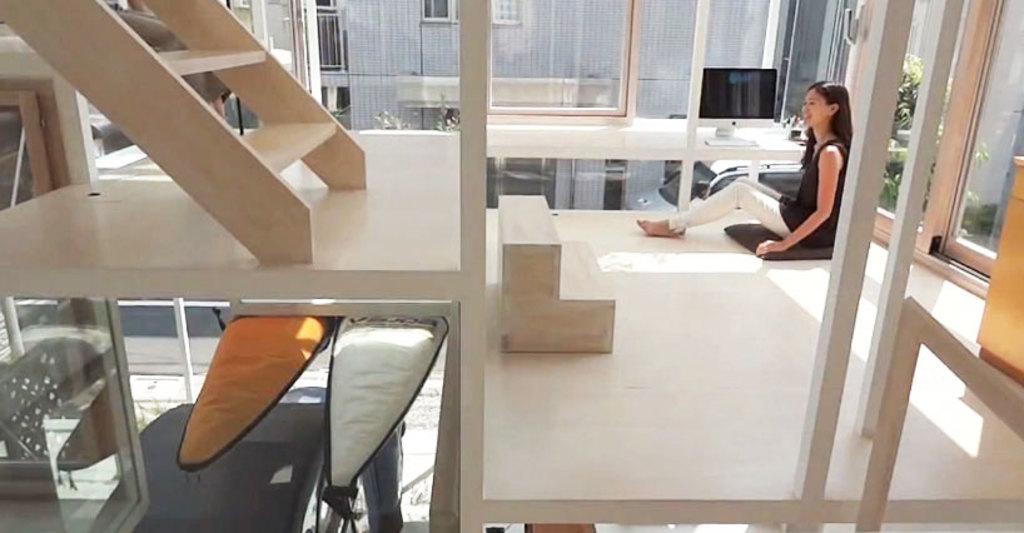Please provide a concise description of this image. In this image on the right side there is one woman who is sitting in front of her there is one television. On the left side there are some stairs and in the bottom there are some objects, and on the floor there is one box and on the background there is a glass window and some buildings are there. 